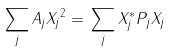<formula> <loc_0><loc_0><loc_500><loc_500>\| \sum _ { j } A _ { j } X _ { j } \| ^ { 2 } = \| \sum _ { j } X _ { j } ^ { * } P _ { j } X _ { j } \|</formula> 